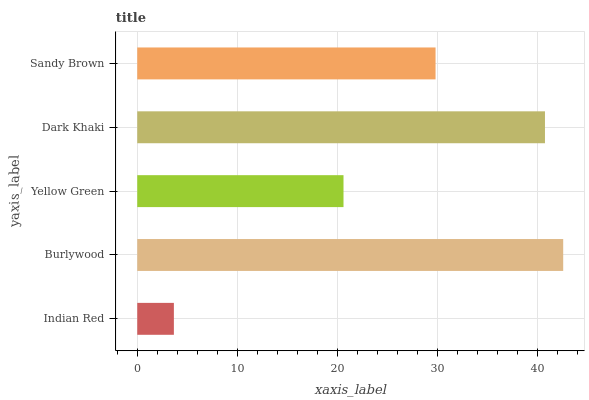Is Indian Red the minimum?
Answer yes or no. Yes. Is Burlywood the maximum?
Answer yes or no. Yes. Is Yellow Green the minimum?
Answer yes or no. No. Is Yellow Green the maximum?
Answer yes or no. No. Is Burlywood greater than Yellow Green?
Answer yes or no. Yes. Is Yellow Green less than Burlywood?
Answer yes or no. Yes. Is Yellow Green greater than Burlywood?
Answer yes or no. No. Is Burlywood less than Yellow Green?
Answer yes or no. No. Is Sandy Brown the high median?
Answer yes or no. Yes. Is Sandy Brown the low median?
Answer yes or no. Yes. Is Yellow Green the high median?
Answer yes or no. No. Is Burlywood the low median?
Answer yes or no. No. 